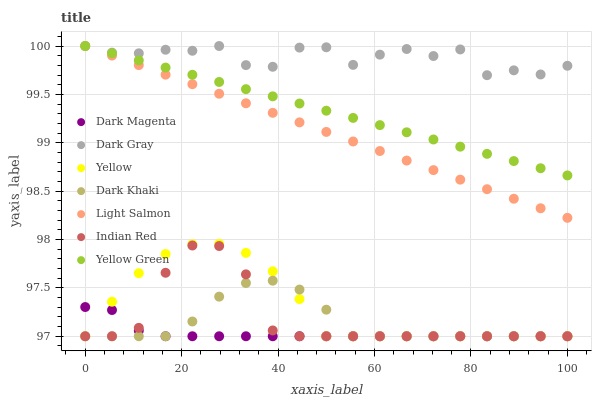Does Dark Magenta have the minimum area under the curve?
Answer yes or no. Yes. Does Dark Gray have the maximum area under the curve?
Answer yes or no. Yes. Does Light Salmon have the minimum area under the curve?
Answer yes or no. No. Does Light Salmon have the maximum area under the curve?
Answer yes or no. No. Is Light Salmon the smoothest?
Answer yes or no. Yes. Is Dark Gray the roughest?
Answer yes or no. Yes. Is Dark Magenta the smoothest?
Answer yes or no. No. Is Dark Magenta the roughest?
Answer yes or no. No. Does Dark Khaki have the lowest value?
Answer yes or no. Yes. Does Light Salmon have the lowest value?
Answer yes or no. No. Does Yellow Green have the highest value?
Answer yes or no. Yes. Does Dark Magenta have the highest value?
Answer yes or no. No. Is Indian Red less than Light Salmon?
Answer yes or no. Yes. Is Light Salmon greater than Dark Khaki?
Answer yes or no. Yes. Does Yellow Green intersect Dark Gray?
Answer yes or no. Yes. Is Yellow Green less than Dark Gray?
Answer yes or no. No. Is Yellow Green greater than Dark Gray?
Answer yes or no. No. Does Indian Red intersect Light Salmon?
Answer yes or no. No. 